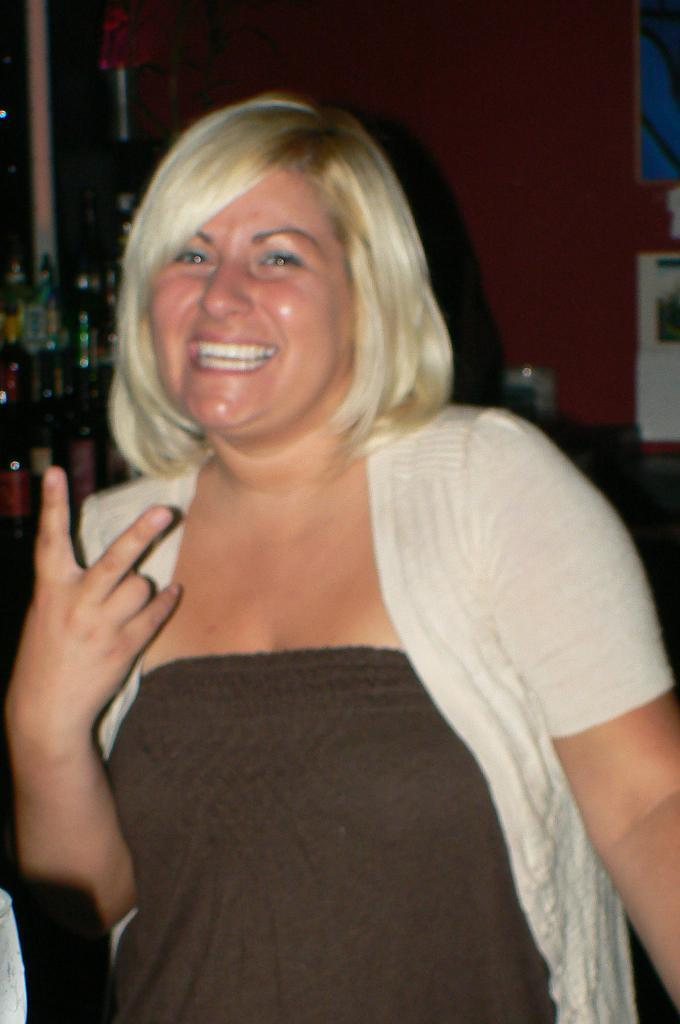Who is the main subject in the image? There is a woman standing in the middle of the image. What is the woman doing in the image? The woman is smiling. What can be seen behind the woman in the image? There are products visible behind the woman. What is the background of the image? There is a wall at the top of the image. How many holidays are celebrated in the image? There is no indication of any holidays being celebrated in the image. What type of place is depicted in the image? The image does not show a specific place; it only shows a woman standing in front of products with a wall in the background. 